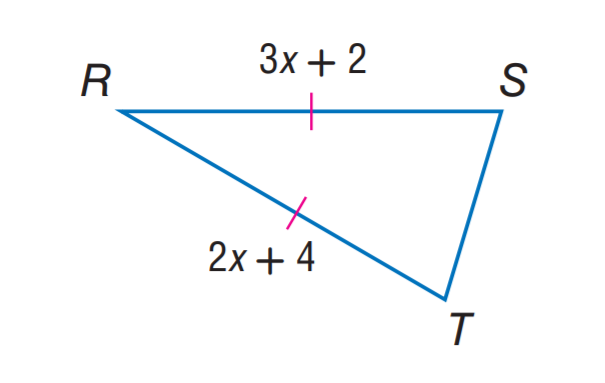Answer the mathemtical geometry problem and directly provide the correct option letter.
Question: Find R T.
Choices: A: 4 B: 6 C: 8 D: 10 C 